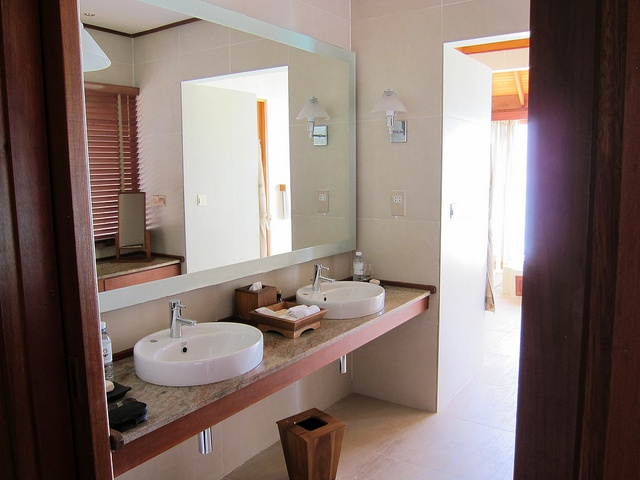Describe the objects in this image and their specific colors. I can see sink in black, darkgray, lightgray, and gray tones, sink in black, darkgray, lightgray, and gray tones, bottle in black, gray, darkgray, and lightgray tones, and bottle in black, darkgray, and gray tones in this image. 